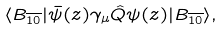<formula> <loc_0><loc_0><loc_500><loc_500>\langle B _ { \overline { 1 0 } } | \bar { \psi } ( z ) \gamma _ { \mu } \hat { Q } \psi ( z ) | B _ { \overline { 1 0 } } \rangle ,</formula> 